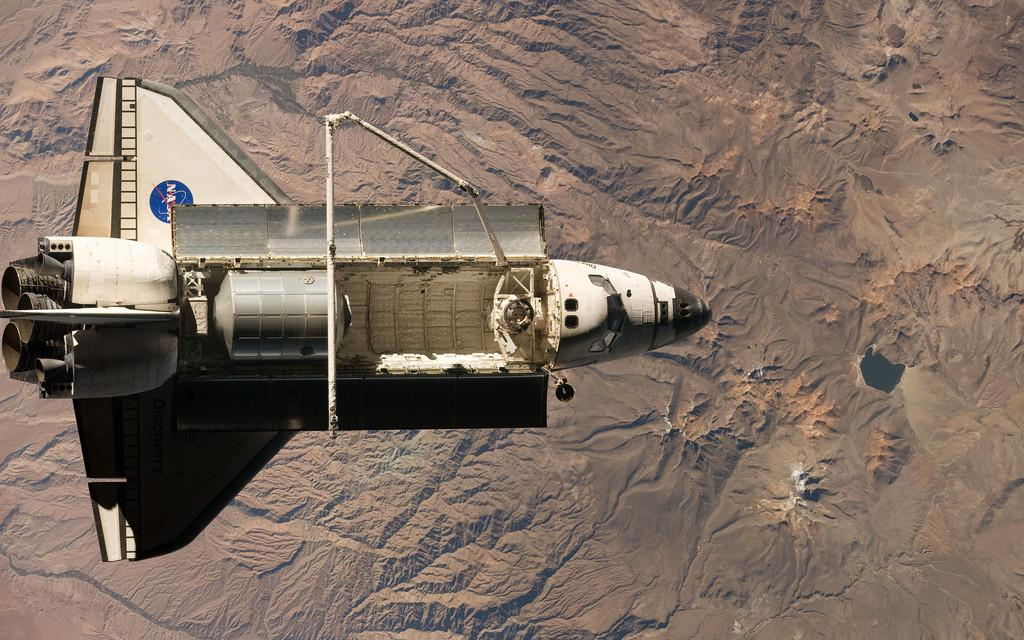What is the main subject of the image? There is a rocket in the image. What is the rocket doing in the image? The rocket is moving in the air. What can be seen in the background of the image? The earth's surface is visible in the background of the image. What type of frame is used to hold the rocket in the image? There is no frame present in the image; the rocket is moving in the air. How does the rocket pan across the sky in the image? The rocket is not shown panning across the sky in the image; it is simply moving in the air. 